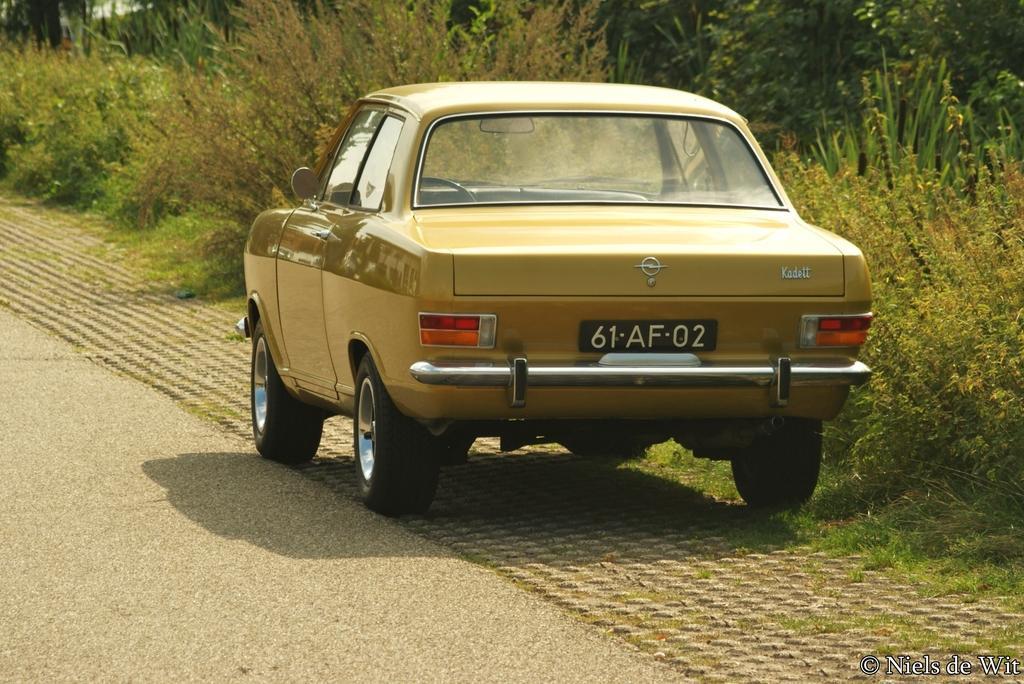Could you give a brief overview of what you see in this image? In this picture we can see a vehicle on the road. Behind the vehicle, there are trees and on the image there is a watermark. 